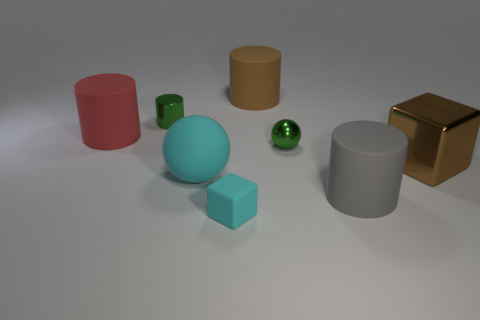There is a ball in front of the metal cube; what is its color?
Ensure brevity in your answer.  Cyan. What is the material of the cylinder that is both right of the big cyan ball and left of the big gray rubber thing?
Offer a terse response. Rubber. What shape is the small object that is made of the same material as the large ball?
Provide a short and direct response. Cube. What number of rubber cylinders are in front of the tiny green shiny object that is behind the small ball?
Your answer should be very brief. 2. How many large rubber things are both in front of the small green metal cylinder and right of the green cylinder?
Give a very brief answer. 2. What number of other objects are the same material as the large cyan object?
Offer a terse response. 4. The rubber cylinder left of the rubber object that is in front of the big gray rubber cylinder is what color?
Offer a very short reply. Red. There is a rubber cylinder that is on the left side of the tiny cyan cube; does it have the same color as the large block?
Your response must be concise. No. Do the gray object and the brown rubber cylinder have the same size?
Your response must be concise. Yes. What is the shape of the cyan object that is the same size as the metallic sphere?
Offer a terse response. Cube. 